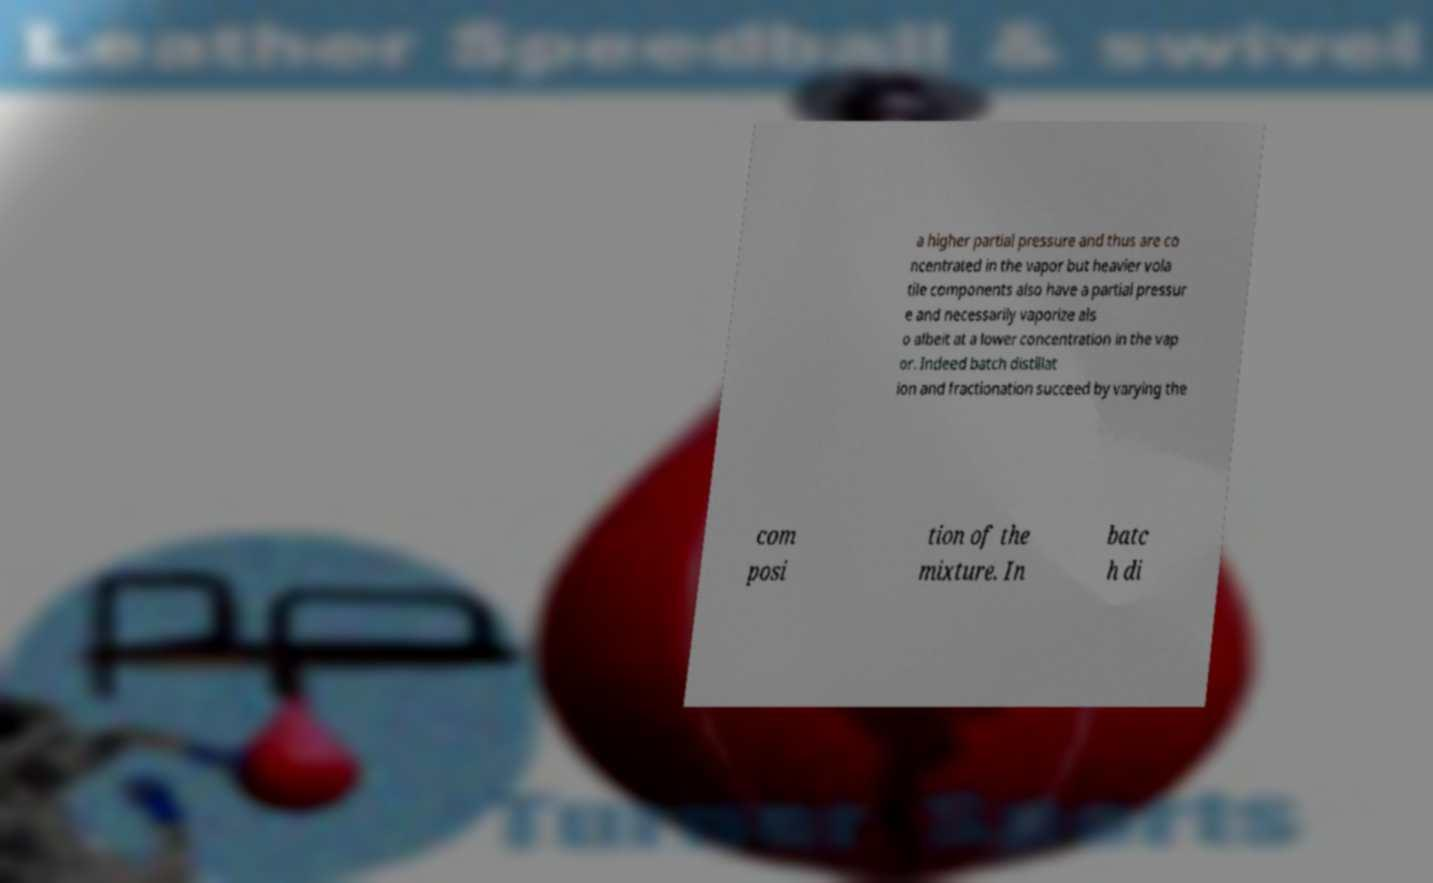Please read and relay the text visible in this image. What does it say? a higher partial pressure and thus are co ncentrated in the vapor but heavier vola tile components also have a partial pressur e and necessarily vaporize als o albeit at a lower concentration in the vap or. Indeed batch distillat ion and fractionation succeed by varying the com posi tion of the mixture. In batc h di 